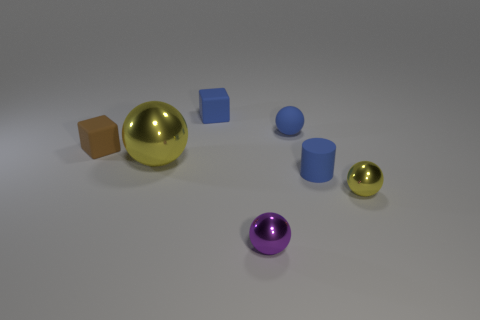There is a small ball that is the same color as the cylinder; what material is it?
Keep it short and to the point. Rubber. Do the matte ball and the cylinder have the same color?
Make the answer very short. Yes. There is a tiny blue thing in front of the large sphere; what is it made of?
Offer a terse response. Rubber. What is the material of the purple thing that is the same size as the blue cylinder?
Keep it short and to the point. Metal. What is the material of the blue thing that is to the left of the ball in front of the small metal thing to the right of the tiny cylinder?
Provide a short and direct response. Rubber. There is a yellow shiny sphere right of the cylinder; does it have the same size as the big sphere?
Your answer should be compact. No. Are there more brown things than yellow balls?
Your response must be concise. No. What number of big things are blue balls or yellow metal objects?
Offer a terse response. 1. How many other objects are the same color as the tiny rubber cylinder?
Provide a short and direct response. 2. What number of yellow things have the same material as the big sphere?
Your answer should be very brief. 1. 